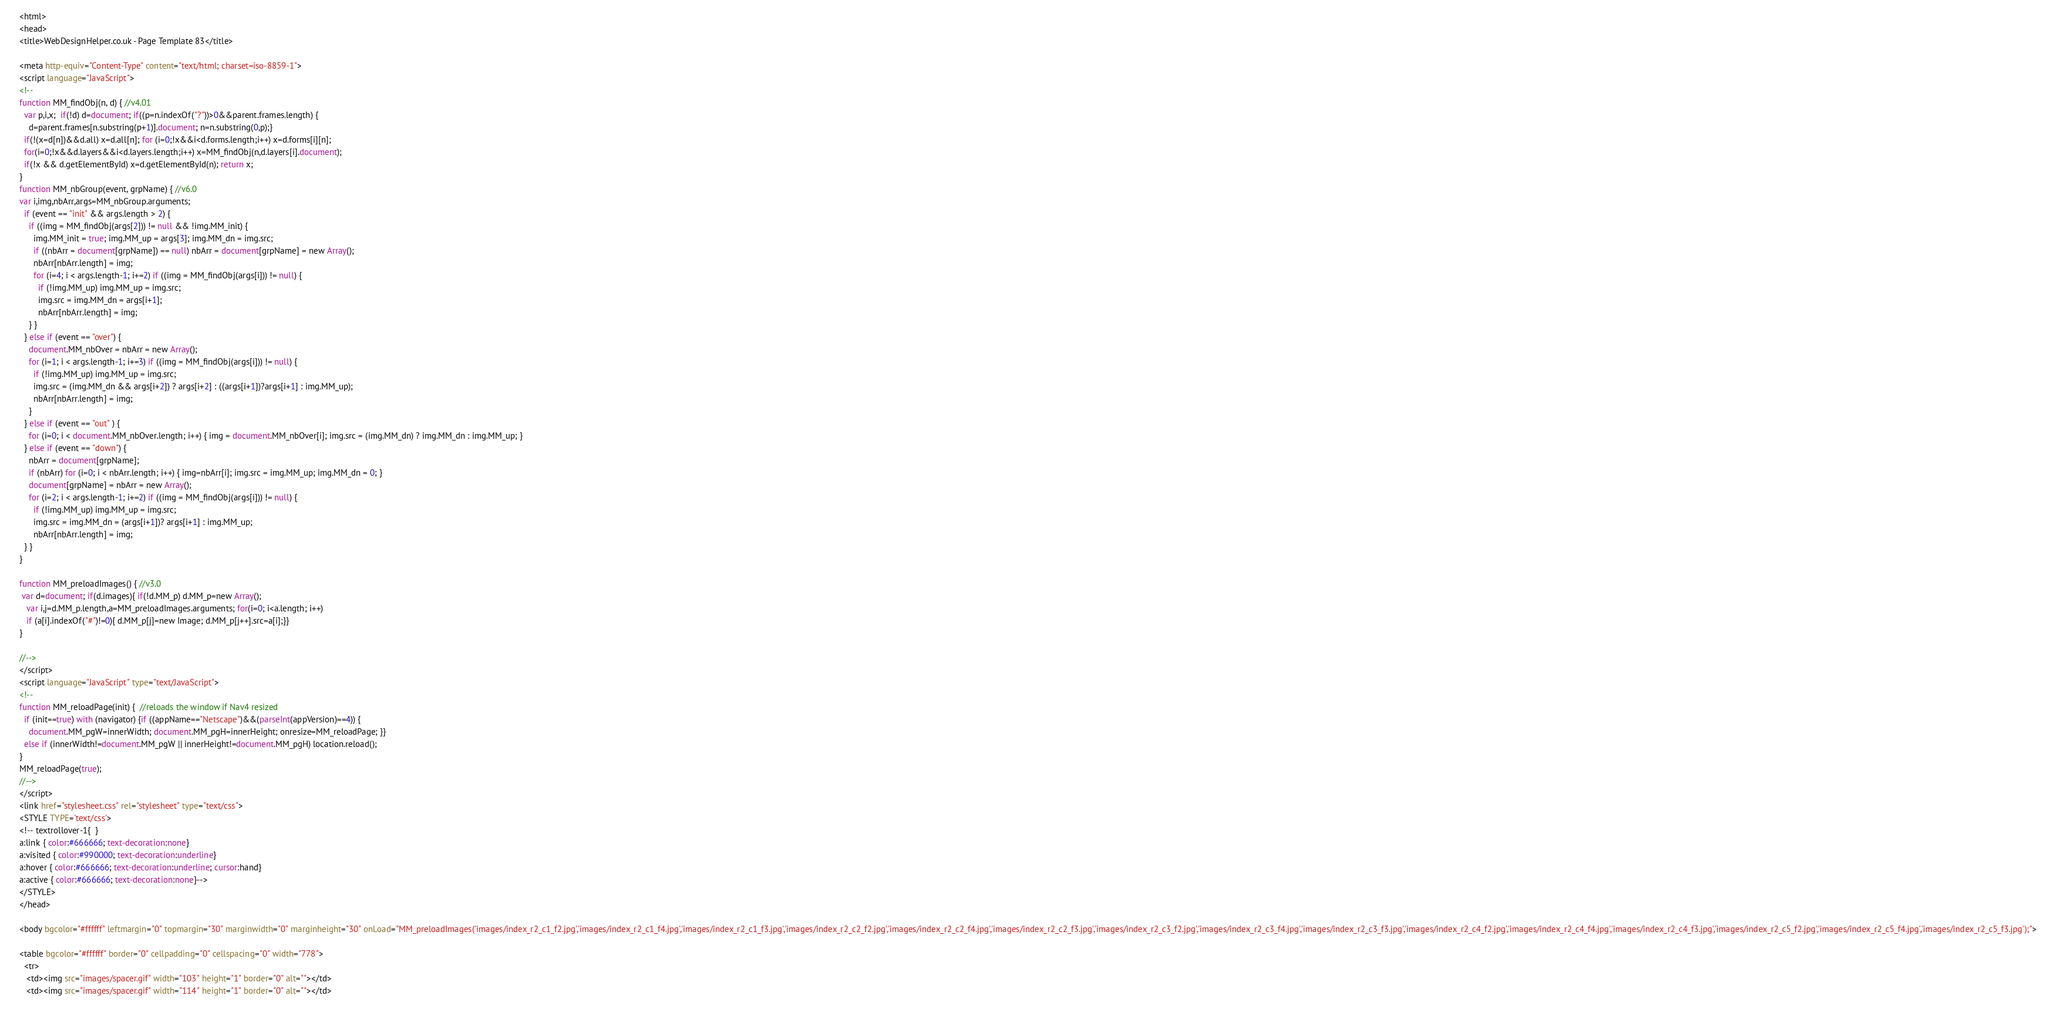<code> <loc_0><loc_0><loc_500><loc_500><_HTML_><html>
<head>
<title>WebDesignHelper.co.uk - Page Template 83</title>

<meta http-equiv="Content-Type" content="text/html; charset=iso-8859-1">
<script language="JavaScript">
<!--
function MM_findObj(n, d) { //v4.01
  var p,i,x;  if(!d) d=document; if((p=n.indexOf("?"))>0&&parent.frames.length) {
    d=parent.frames[n.substring(p+1)].document; n=n.substring(0,p);}
  if(!(x=d[n])&&d.all) x=d.all[n]; for (i=0;!x&&i<d.forms.length;i++) x=d.forms[i][n];
  for(i=0;!x&&d.layers&&i<d.layers.length;i++) x=MM_findObj(n,d.layers[i].document);
  if(!x && d.getElementById) x=d.getElementById(n); return x;
}
function MM_nbGroup(event, grpName) { //v6.0
var i,img,nbArr,args=MM_nbGroup.arguments;
  if (event == "init" && args.length > 2) {
    if ((img = MM_findObj(args[2])) != null && !img.MM_init) {
      img.MM_init = true; img.MM_up = args[3]; img.MM_dn = img.src;
      if ((nbArr = document[grpName]) == null) nbArr = document[grpName] = new Array();
      nbArr[nbArr.length] = img;
      for (i=4; i < args.length-1; i+=2) if ((img = MM_findObj(args[i])) != null) {
        if (!img.MM_up) img.MM_up = img.src;
        img.src = img.MM_dn = args[i+1];
        nbArr[nbArr.length] = img;
    } }
  } else if (event == "over") {
    document.MM_nbOver = nbArr = new Array();
    for (i=1; i < args.length-1; i+=3) if ((img = MM_findObj(args[i])) != null) {
      if (!img.MM_up) img.MM_up = img.src;
      img.src = (img.MM_dn && args[i+2]) ? args[i+2] : ((args[i+1])?args[i+1] : img.MM_up);
      nbArr[nbArr.length] = img;
    }
  } else if (event == "out" ) {
    for (i=0; i < document.MM_nbOver.length; i++) { img = document.MM_nbOver[i]; img.src = (img.MM_dn) ? img.MM_dn : img.MM_up; }
  } else if (event == "down") {
    nbArr = document[grpName];
    if (nbArr) for (i=0; i < nbArr.length; i++) { img=nbArr[i]; img.src = img.MM_up; img.MM_dn = 0; }
    document[grpName] = nbArr = new Array();
    for (i=2; i < args.length-1; i+=2) if ((img = MM_findObj(args[i])) != null) {
      if (!img.MM_up) img.MM_up = img.src;
      img.src = img.MM_dn = (args[i+1])? args[i+1] : img.MM_up;
      nbArr[nbArr.length] = img;
  } }
}

function MM_preloadImages() { //v3.0
 var d=document; if(d.images){ if(!d.MM_p) d.MM_p=new Array();
   var i,j=d.MM_p.length,a=MM_preloadImages.arguments; for(i=0; i<a.length; i++)
   if (a[i].indexOf("#")!=0){ d.MM_p[j]=new Image; d.MM_p[j++].src=a[i];}}
}

//-->
</script>
<script language="JavaScript" type="text/JavaScript">
<!--
function MM_reloadPage(init) {  //reloads the window if Nav4 resized
  if (init==true) with (navigator) {if ((appName=="Netscape")&&(parseInt(appVersion)==4)) {
    document.MM_pgW=innerWidth; document.MM_pgH=innerHeight; onresize=MM_reloadPage; }}
  else if (innerWidth!=document.MM_pgW || innerHeight!=document.MM_pgH) location.reload();
}
MM_reloadPage(true);
//-->
</script>
<link href="stylesheet.css" rel="stylesheet" type="text/css">
<STYLE TYPE='text/css'>
<!-- textrollover-1{  }
a:link { color:#666666; text-decoration:none}
a:visited { color:#990000; text-decoration:underline}
a:hover { color:#666666; text-decoration:underline; cursor:hand}
a:active { color:#666666; text-decoration:none}-->
</STYLE>
</head>

<body bgcolor="#ffffff" leftmargin="0" topmargin="30" marginwidth="0" marginheight="30" onLoad="MM_preloadImages('images/index_r2_c1_f2.jpg','images/index_r2_c1_f4.jpg','images/index_r2_c1_f3.jpg','images/index_r2_c2_f2.jpg','images/index_r2_c2_f4.jpg','images/index_r2_c2_f3.jpg','images/index_r2_c3_f2.jpg','images/index_r2_c3_f4.jpg','images/index_r2_c3_f3.jpg','images/index_r2_c4_f2.jpg','images/index_r2_c4_f4.jpg','images/index_r2_c4_f3.jpg','images/index_r2_c5_f2.jpg','images/index_r2_c5_f4.jpg','images/index_r2_c5_f3.jpg');">

<table bgcolor="#ffffff" border="0" cellpadding="0" cellspacing="0" width="778">
  <tr> 
   <td><img src="images/spacer.gif" width="103" height="1" border="0" alt=""></td>
   <td><img src="images/spacer.gif" width="114" height="1" border="0" alt=""></td></code> 